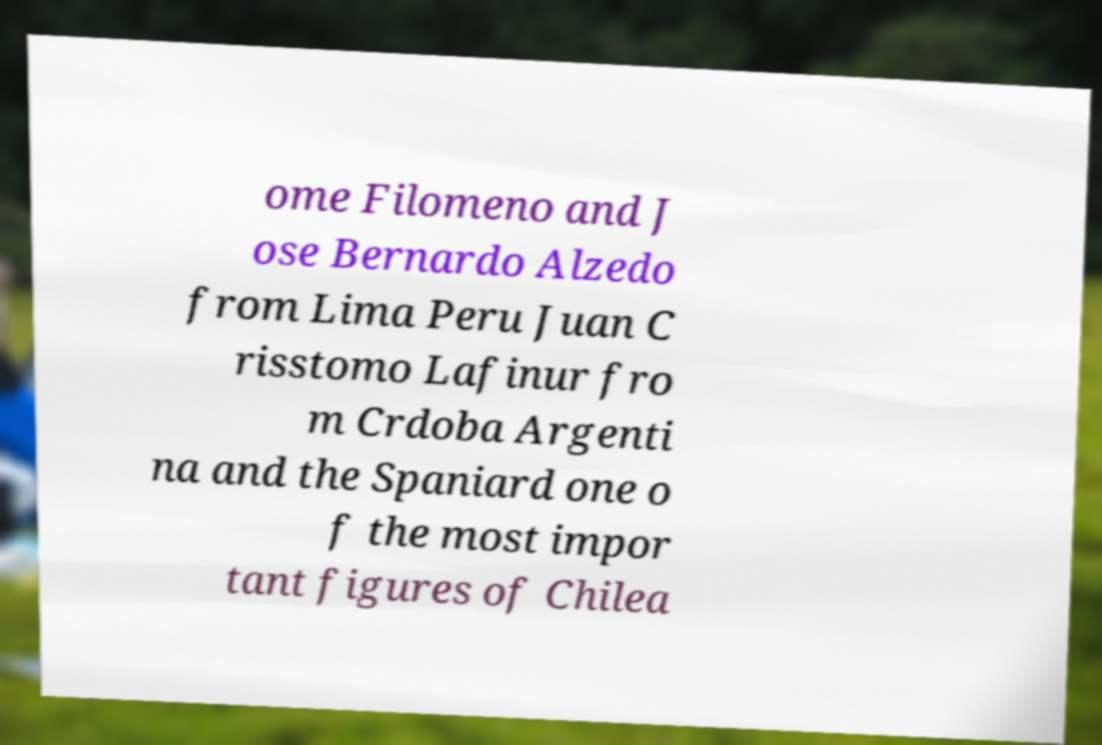Can you accurately transcribe the text from the provided image for me? ome Filomeno and J ose Bernardo Alzedo from Lima Peru Juan C risstomo Lafinur fro m Crdoba Argenti na and the Spaniard one o f the most impor tant figures of Chilea 